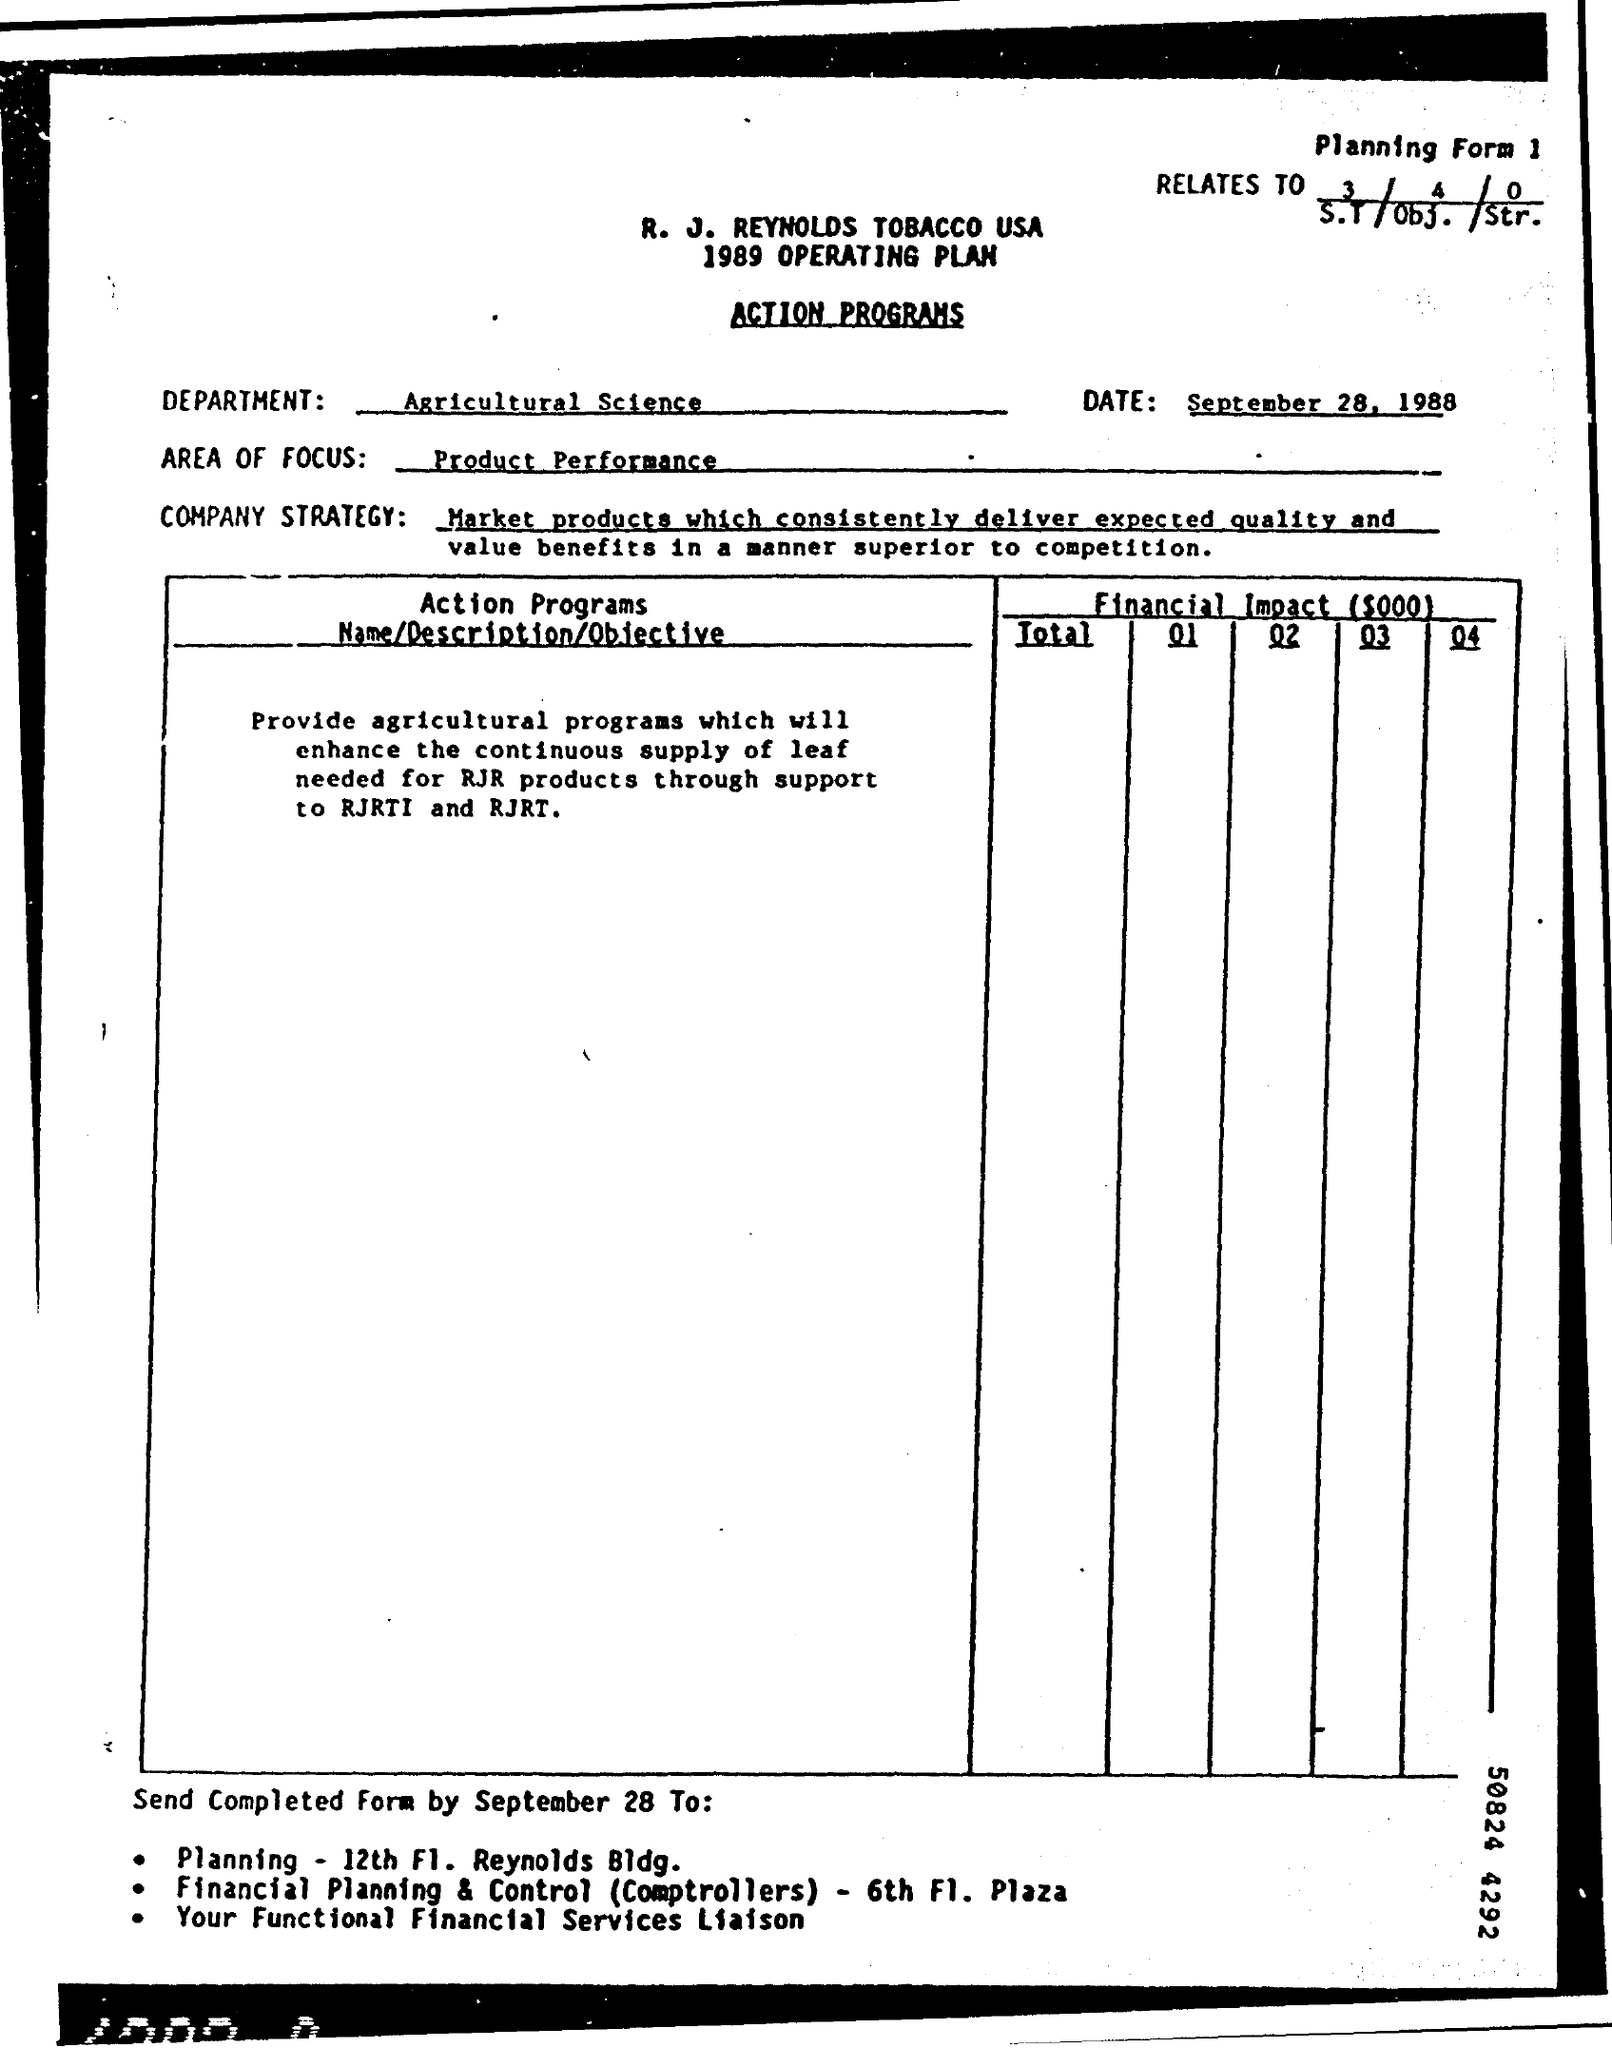Date of sending the document?
Your answer should be compact. September 28. Find the area of focus written in the page?
Offer a very short reply. Product Performance. Find the department's name mentioned?
Provide a succinct answer. Agricultural Science. 